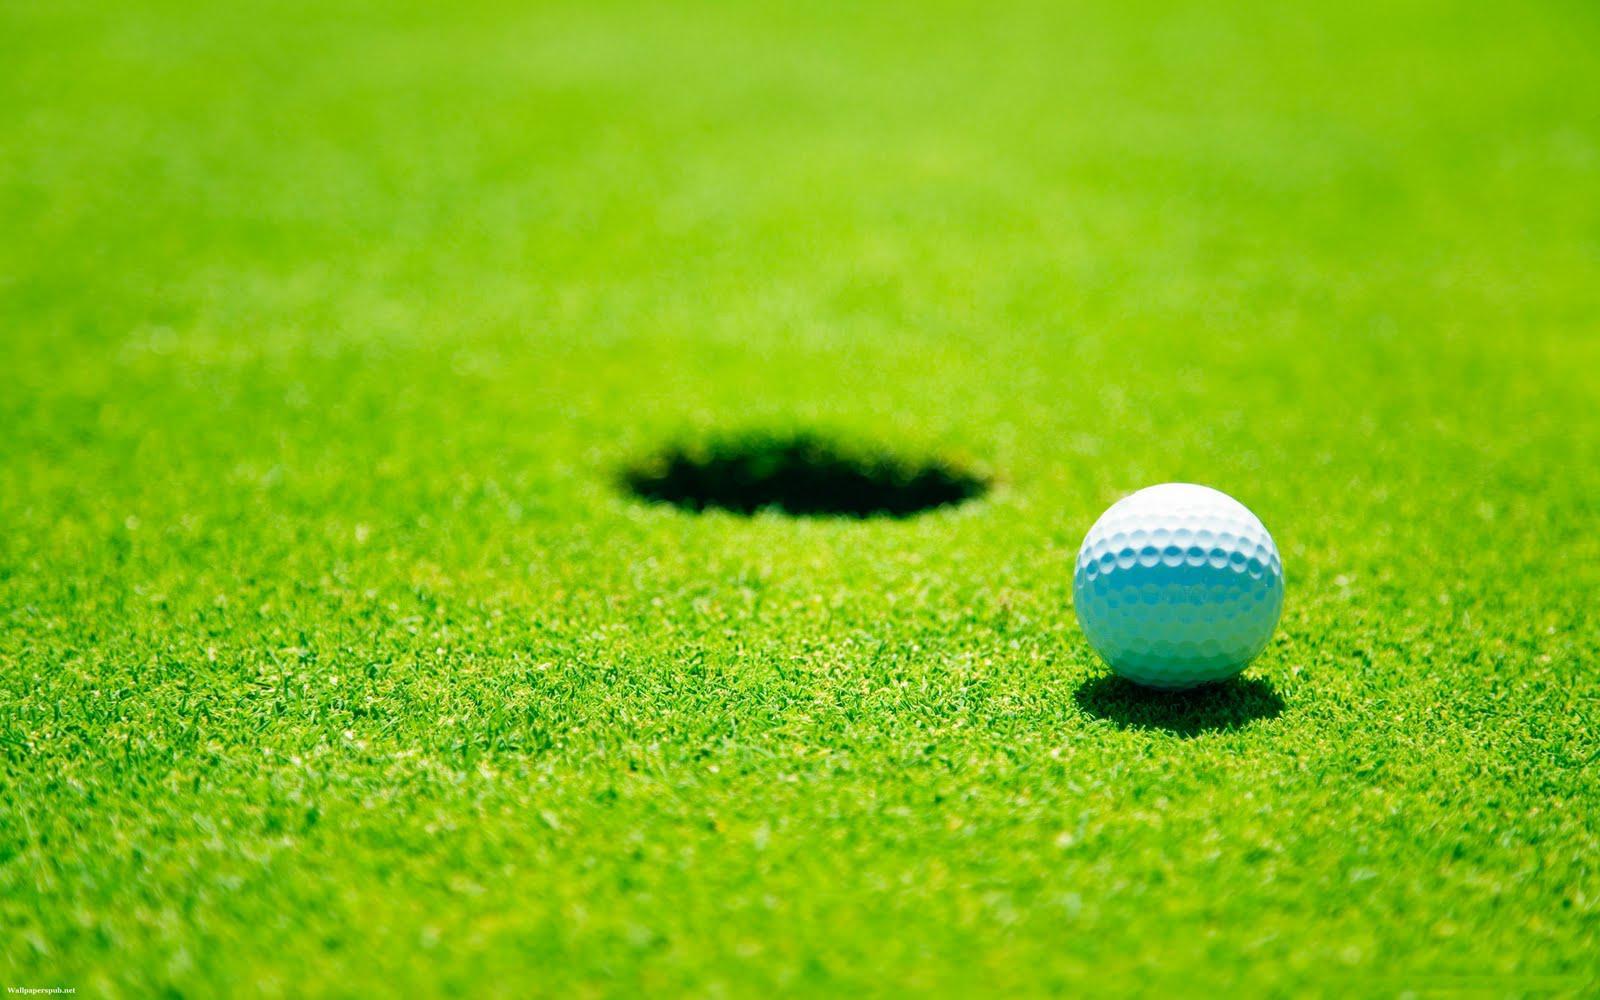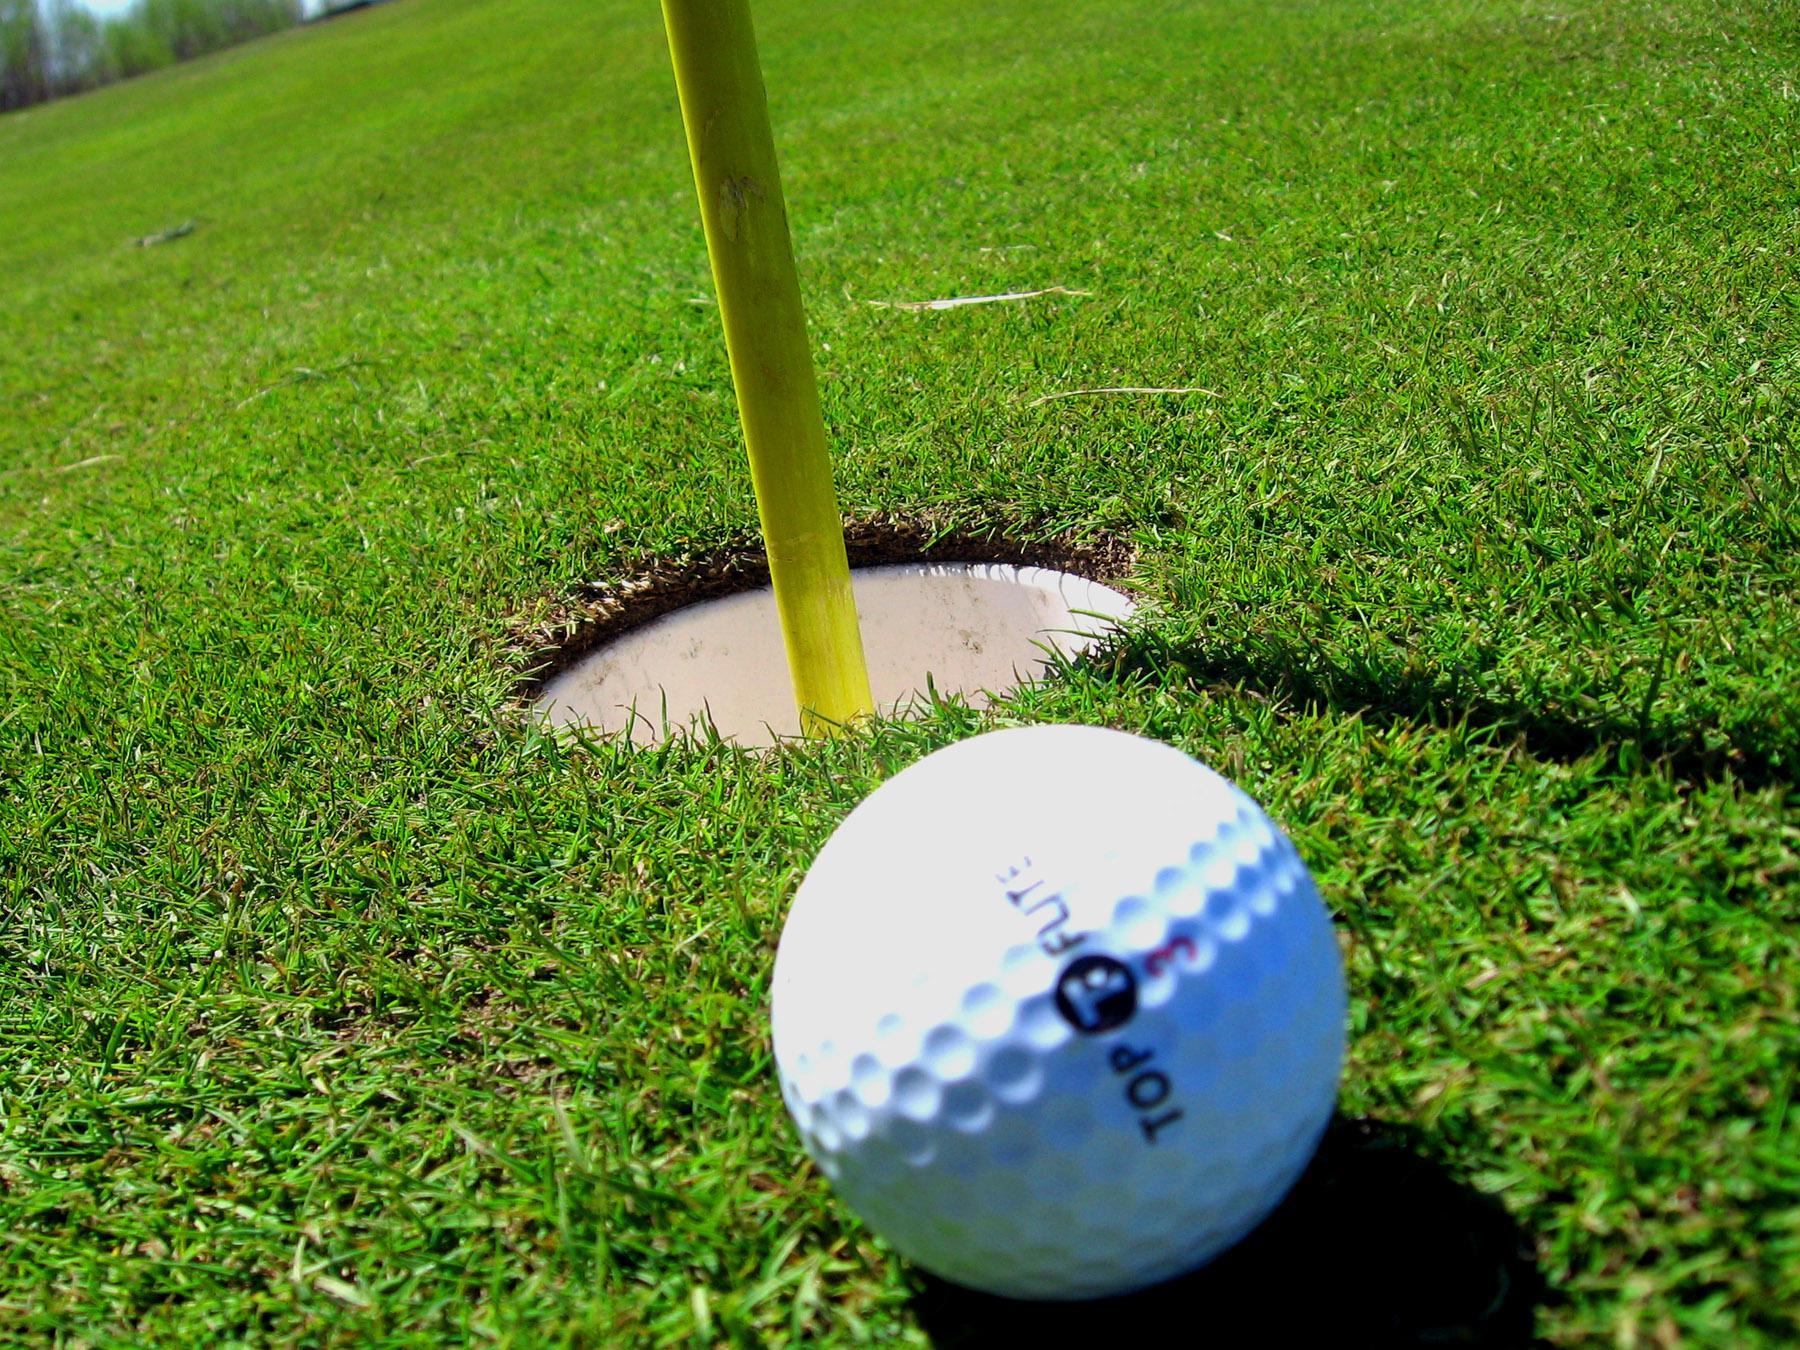The first image is the image on the left, the second image is the image on the right. Assess this claim about the two images: "Left image shows one ball next to a hole on a golf green.". Correct or not? Answer yes or no. Yes. The first image is the image on the left, the second image is the image on the right. Analyze the images presented: Is the assertion "Each image shows one golf ball on a green, one of them near a cup with a flag pole." valid? Answer yes or no. Yes. 